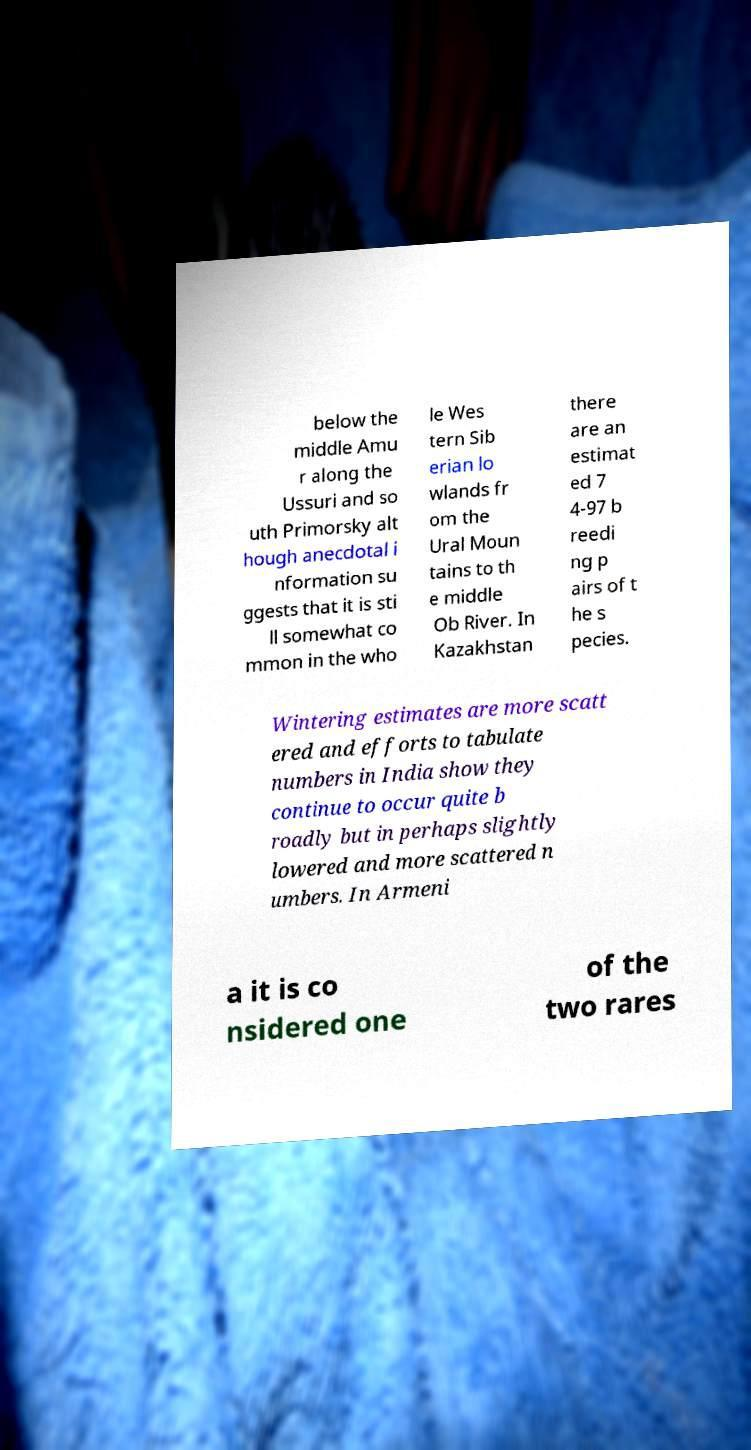For documentation purposes, I need the text within this image transcribed. Could you provide that? below the middle Amu r along the Ussuri and so uth Primorsky alt hough anecdotal i nformation su ggests that it is sti ll somewhat co mmon in the who le Wes tern Sib erian lo wlands fr om the Ural Moun tains to th e middle Ob River. In Kazakhstan there are an estimat ed 7 4-97 b reedi ng p airs of t he s pecies. Wintering estimates are more scatt ered and efforts to tabulate numbers in India show they continue to occur quite b roadly but in perhaps slightly lowered and more scattered n umbers. In Armeni a it is co nsidered one of the two rares 